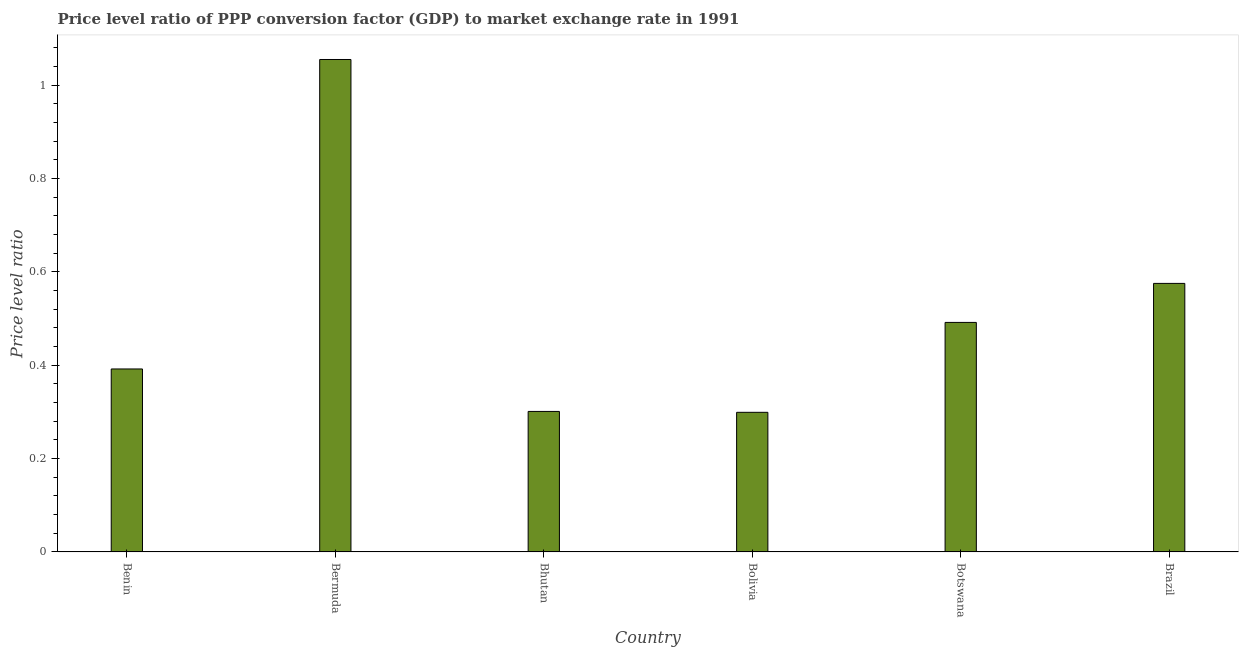Does the graph contain grids?
Make the answer very short. No. What is the title of the graph?
Your answer should be compact. Price level ratio of PPP conversion factor (GDP) to market exchange rate in 1991. What is the label or title of the Y-axis?
Offer a terse response. Price level ratio. What is the price level ratio in Brazil?
Your answer should be compact. 0.58. Across all countries, what is the maximum price level ratio?
Your answer should be very brief. 1.05. Across all countries, what is the minimum price level ratio?
Give a very brief answer. 0.3. In which country was the price level ratio maximum?
Your answer should be very brief. Bermuda. What is the sum of the price level ratio?
Provide a succinct answer. 3.11. What is the difference between the price level ratio in Benin and Bolivia?
Offer a terse response. 0.09. What is the average price level ratio per country?
Your response must be concise. 0.52. What is the median price level ratio?
Ensure brevity in your answer.  0.44. In how many countries, is the price level ratio greater than 0.24 ?
Your answer should be very brief. 6. What is the ratio of the price level ratio in Bolivia to that in Brazil?
Provide a short and direct response. 0.52. Is the difference between the price level ratio in Benin and Bhutan greater than the difference between any two countries?
Your response must be concise. No. What is the difference between the highest and the second highest price level ratio?
Keep it short and to the point. 0.48. Is the sum of the price level ratio in Bolivia and Brazil greater than the maximum price level ratio across all countries?
Provide a succinct answer. No. What is the difference between the highest and the lowest price level ratio?
Make the answer very short. 0.76. How many bars are there?
Your answer should be very brief. 6. Are all the bars in the graph horizontal?
Your answer should be very brief. No. How many countries are there in the graph?
Give a very brief answer. 6. What is the difference between two consecutive major ticks on the Y-axis?
Your answer should be very brief. 0.2. What is the Price level ratio of Benin?
Offer a terse response. 0.39. What is the Price level ratio of Bermuda?
Provide a short and direct response. 1.05. What is the Price level ratio of Bhutan?
Ensure brevity in your answer.  0.3. What is the Price level ratio in Bolivia?
Make the answer very short. 0.3. What is the Price level ratio in Botswana?
Keep it short and to the point. 0.49. What is the Price level ratio in Brazil?
Make the answer very short. 0.58. What is the difference between the Price level ratio in Benin and Bermuda?
Provide a short and direct response. -0.66. What is the difference between the Price level ratio in Benin and Bhutan?
Ensure brevity in your answer.  0.09. What is the difference between the Price level ratio in Benin and Bolivia?
Offer a very short reply. 0.09. What is the difference between the Price level ratio in Benin and Botswana?
Your response must be concise. -0.1. What is the difference between the Price level ratio in Benin and Brazil?
Offer a terse response. -0.18. What is the difference between the Price level ratio in Bermuda and Bhutan?
Keep it short and to the point. 0.75. What is the difference between the Price level ratio in Bermuda and Bolivia?
Offer a terse response. 0.76. What is the difference between the Price level ratio in Bermuda and Botswana?
Give a very brief answer. 0.56. What is the difference between the Price level ratio in Bermuda and Brazil?
Keep it short and to the point. 0.48. What is the difference between the Price level ratio in Bhutan and Bolivia?
Give a very brief answer. 0. What is the difference between the Price level ratio in Bhutan and Botswana?
Provide a short and direct response. -0.19. What is the difference between the Price level ratio in Bhutan and Brazil?
Offer a very short reply. -0.27. What is the difference between the Price level ratio in Bolivia and Botswana?
Ensure brevity in your answer.  -0.19. What is the difference between the Price level ratio in Bolivia and Brazil?
Provide a succinct answer. -0.28. What is the difference between the Price level ratio in Botswana and Brazil?
Offer a very short reply. -0.08. What is the ratio of the Price level ratio in Benin to that in Bermuda?
Your answer should be compact. 0.37. What is the ratio of the Price level ratio in Benin to that in Bhutan?
Offer a very short reply. 1.3. What is the ratio of the Price level ratio in Benin to that in Bolivia?
Ensure brevity in your answer.  1.31. What is the ratio of the Price level ratio in Benin to that in Botswana?
Give a very brief answer. 0.8. What is the ratio of the Price level ratio in Benin to that in Brazil?
Your answer should be very brief. 0.68. What is the ratio of the Price level ratio in Bermuda to that in Bhutan?
Offer a terse response. 3.5. What is the ratio of the Price level ratio in Bermuda to that in Bolivia?
Your answer should be compact. 3.53. What is the ratio of the Price level ratio in Bermuda to that in Botswana?
Give a very brief answer. 2.15. What is the ratio of the Price level ratio in Bermuda to that in Brazil?
Give a very brief answer. 1.83. What is the ratio of the Price level ratio in Bhutan to that in Botswana?
Provide a short and direct response. 0.61. What is the ratio of the Price level ratio in Bhutan to that in Brazil?
Offer a terse response. 0.52. What is the ratio of the Price level ratio in Bolivia to that in Botswana?
Offer a terse response. 0.61. What is the ratio of the Price level ratio in Bolivia to that in Brazil?
Offer a terse response. 0.52. What is the ratio of the Price level ratio in Botswana to that in Brazil?
Your response must be concise. 0.85. 